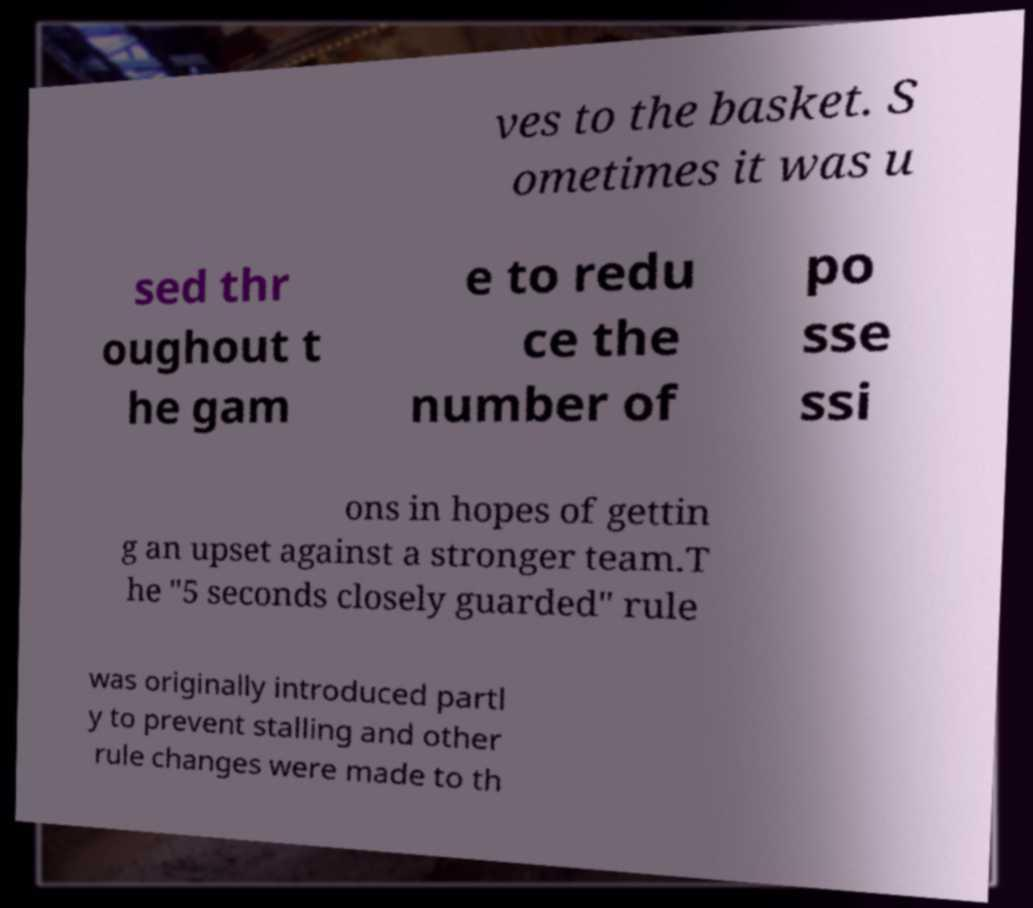Can you accurately transcribe the text from the provided image for me? ves to the basket. S ometimes it was u sed thr oughout t he gam e to redu ce the number of po sse ssi ons in hopes of gettin g an upset against a stronger team.T he "5 seconds closely guarded" rule was originally introduced partl y to prevent stalling and other rule changes were made to th 